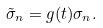Convert formula to latex. <formula><loc_0><loc_0><loc_500><loc_500>\tilde { \sigma } _ { n } = g ( t ) \sigma _ { n } .</formula> 